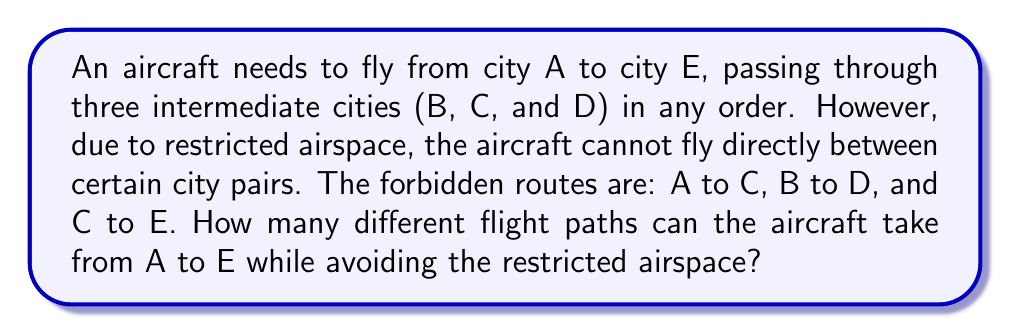Help me with this question. Let's approach this step-by-step:

1) First, we need to understand the problem structure. We have 5 cities (A, B, C, D, E) and the aircraft must visit all of them.

2) The start (A) and end (E) points are fixed, so we need to arrange the other 3 cities (B, C, D) in between.

3) Normally, this would be a simple permutation of 3 cities, which would give us 3! = 6 possible arrangements.

4) However, we have restrictions:
   - A cannot be directly followed by C
   - B cannot be directly followed by D
   - C cannot be directly followed by E

5) Let's list all possible permutations of B, C, and D, and then eliminate the ones that violate our restrictions:

   ABCDE
   ABDCE
   ACBDE (violates A-C restriction)
   ACDBE
   ADBCE
   ADCBE

6) We see that only one permutation (ACBDE) violates our restrictions.

7) Therefore, the number of valid flight paths is 5.

This problem demonstrates the importance of considering operational constraints in flight path planning, which is crucial for optimizing aircraft performance while adhering to airspace regulations.
Answer: 5 different flight paths 